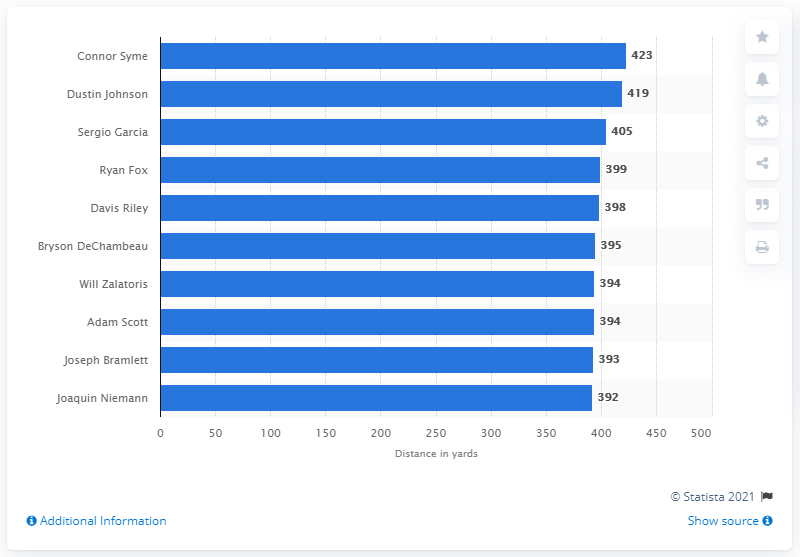Indicate a few pertinent items in this graphic. In 2020, Connor Syme was the top golfer on the PGA tour. 